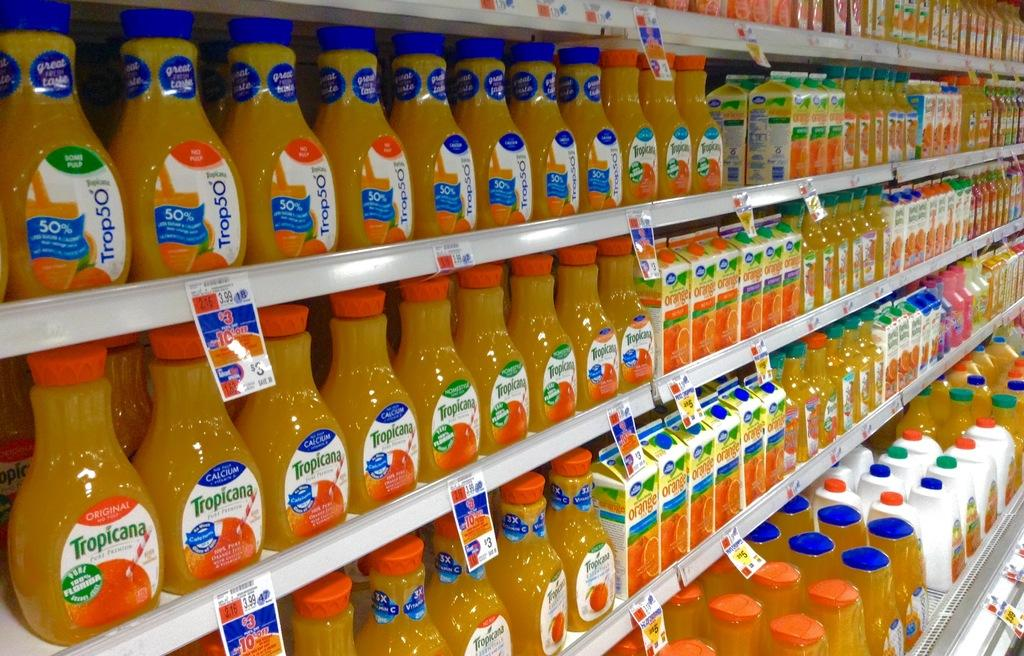What type of objects can be seen in the image? There are bottles in the image. How are the objects arranged in the image? The objects are arranged on shelves in the image. What additional decorations can be seen on the shelves? Stickers are attached to the shelves in the image. What type of noise can be heard coming from the tub in the image? There is no tub present in the image, so it is not possible to determine what, if any, noise might be heard. 